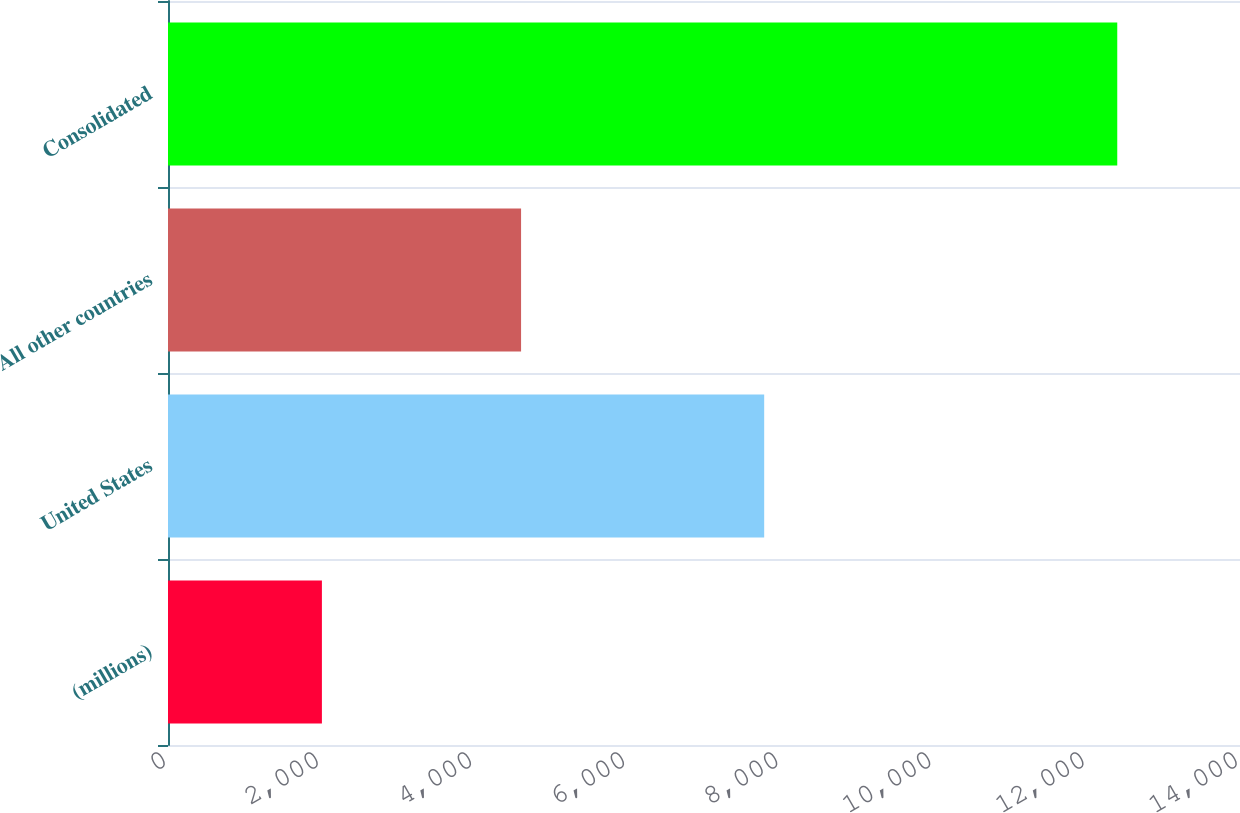Convert chart to OTSL. <chart><loc_0><loc_0><loc_500><loc_500><bar_chart><fcel>(millions)<fcel>United States<fcel>All other countries<fcel>Consolidated<nl><fcel>2010<fcel>7786<fcel>4611<fcel>12397<nl></chart> 